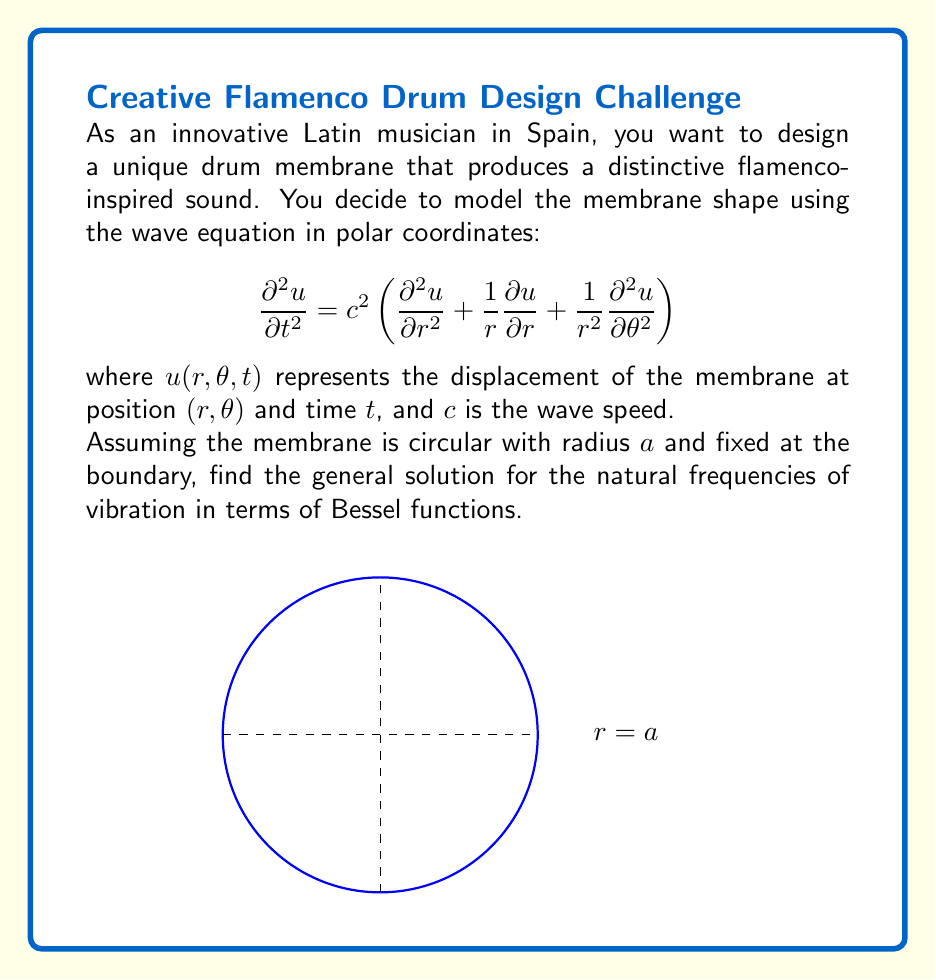Show me your answer to this math problem. To solve this problem, we'll follow these steps:

1) Separate variables: Assume $u(r,\theta,t) = R(r)\Theta(\theta)T(t)$

2) Substitute into the wave equation:

   $$\frac{T''}{c^2T} = \frac{R''}{R} + \frac{1}{r}\frac{R'}{R} + \frac{1}{r^2}\frac{\Theta''}{\Theta} = -k^2$$

3) This leads to three separate equations:
   
   Time: $T'' + c^2k^2T = 0$
   Angular: $\Theta'' + m^2\Theta = 0$
   Radial: $r^2R'' + rR' + (k^2r^2 - m^2)R = 0$

4) The time equation gives us $T(t) = A\cos(c k t) + B\sin(c k t)$

5) The angular equation gives us $\Theta(\theta) = C\cos(m\theta) + D\sin(m\theta)$, where $m$ must be an integer for periodicity.

6) The radial equation is a Bessel equation. Its solution is:
   
   $R(r) = EJ_m(kr) + FY_m(kr)$

   where $J_m$ and $Y_m$ are Bessel functions of the first and second kind.

7) Since $Y_m$ is singular at $r=0$, we must have $F=0$ for a physically meaningful solution.

8) The boundary condition $u(a,\theta,t) = 0$ implies $J_m(ka) = 0$

9) Let $\alpha_{mn}$ be the nth zero of $J_m$. Then the natural frequencies are given by:

   $$\omega_{mn} = \frac{c\alpha_{mn}}{a}$$

Thus, the general solution is:

$$u(r,\theta,t) = \sum_{m=0}^\infty \sum_{n=1}^\infty A_{mn}J_m\left(\frac{\alpha_{mn}r}{a}\right)[C_m\cos(m\theta) + D_m\sin(m\theta)]\cos\left(\frac{c\alpha_{mn}t}{a}\right)$$

where $A_{mn}$, $C_m$, and $D_m$ are constants determined by initial conditions.
Answer: $\omega_{mn} = \frac{c\alpha_{mn}}{a}$, where $\alpha_{mn}$ is the nth zero of $J_m(x)$. 